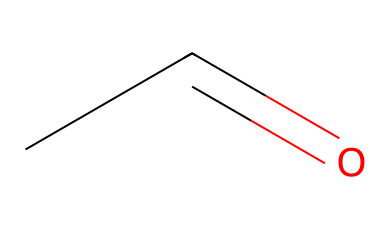What is the total number of carbon atoms in acetaldehyde? The SMILES representation "CC=O" indicates that there are two carbon atoms (the two 'C's before the '=').
Answer: 2 How many hydrogen atoms are present in acetaldehyde? In the structure of acetaldehyde "CC=O", there are five hydrogen atoms connected to the two carbon atoms (1 to the terminal carbon and 3 to the other carbon, accounting for the double bond with oxygen).
Answer: 4 What type of functional group is present in acetaldehyde? The structure shows a carbonyl group (C=O), which is characteristic of aldehydes. The presence of the carbonyl attached to a terminal carbon confirms it as an aldehyde.
Answer: aldehyde What is the molecular formula of acetaldehyde? By counting the atoms in the SMILES representation "CC=O", we find 2 carbon (C), 4 hydrogen (H), and 1 oxygen (O), leading to the formula C2H4O.
Answer: C2H4O Is acetaldehyde a saturated or unsaturated compound? The presence of a double bond between the carbon and oxygen (C=O) indicates that acetaldehyde is an unsaturated compound.
Answer: unsaturated 